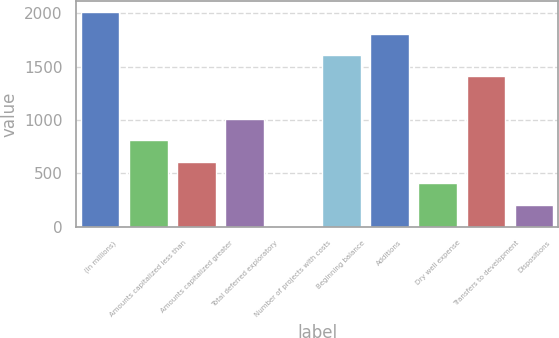Convert chart to OTSL. <chart><loc_0><loc_0><loc_500><loc_500><bar_chart><fcel>(In millions)<fcel>Amounts capitalized less than<fcel>Amounts capitalized greater<fcel>Total deferred exploratory<fcel>Number of projects with costs<fcel>Beginning balance<fcel>Additions<fcel>Dry well expense<fcel>Transfers to development<fcel>Dispositions<nl><fcel>2012<fcel>808.4<fcel>607.8<fcel>1009<fcel>6<fcel>1610.8<fcel>1811.4<fcel>407.2<fcel>1410.2<fcel>206.6<nl></chart> 